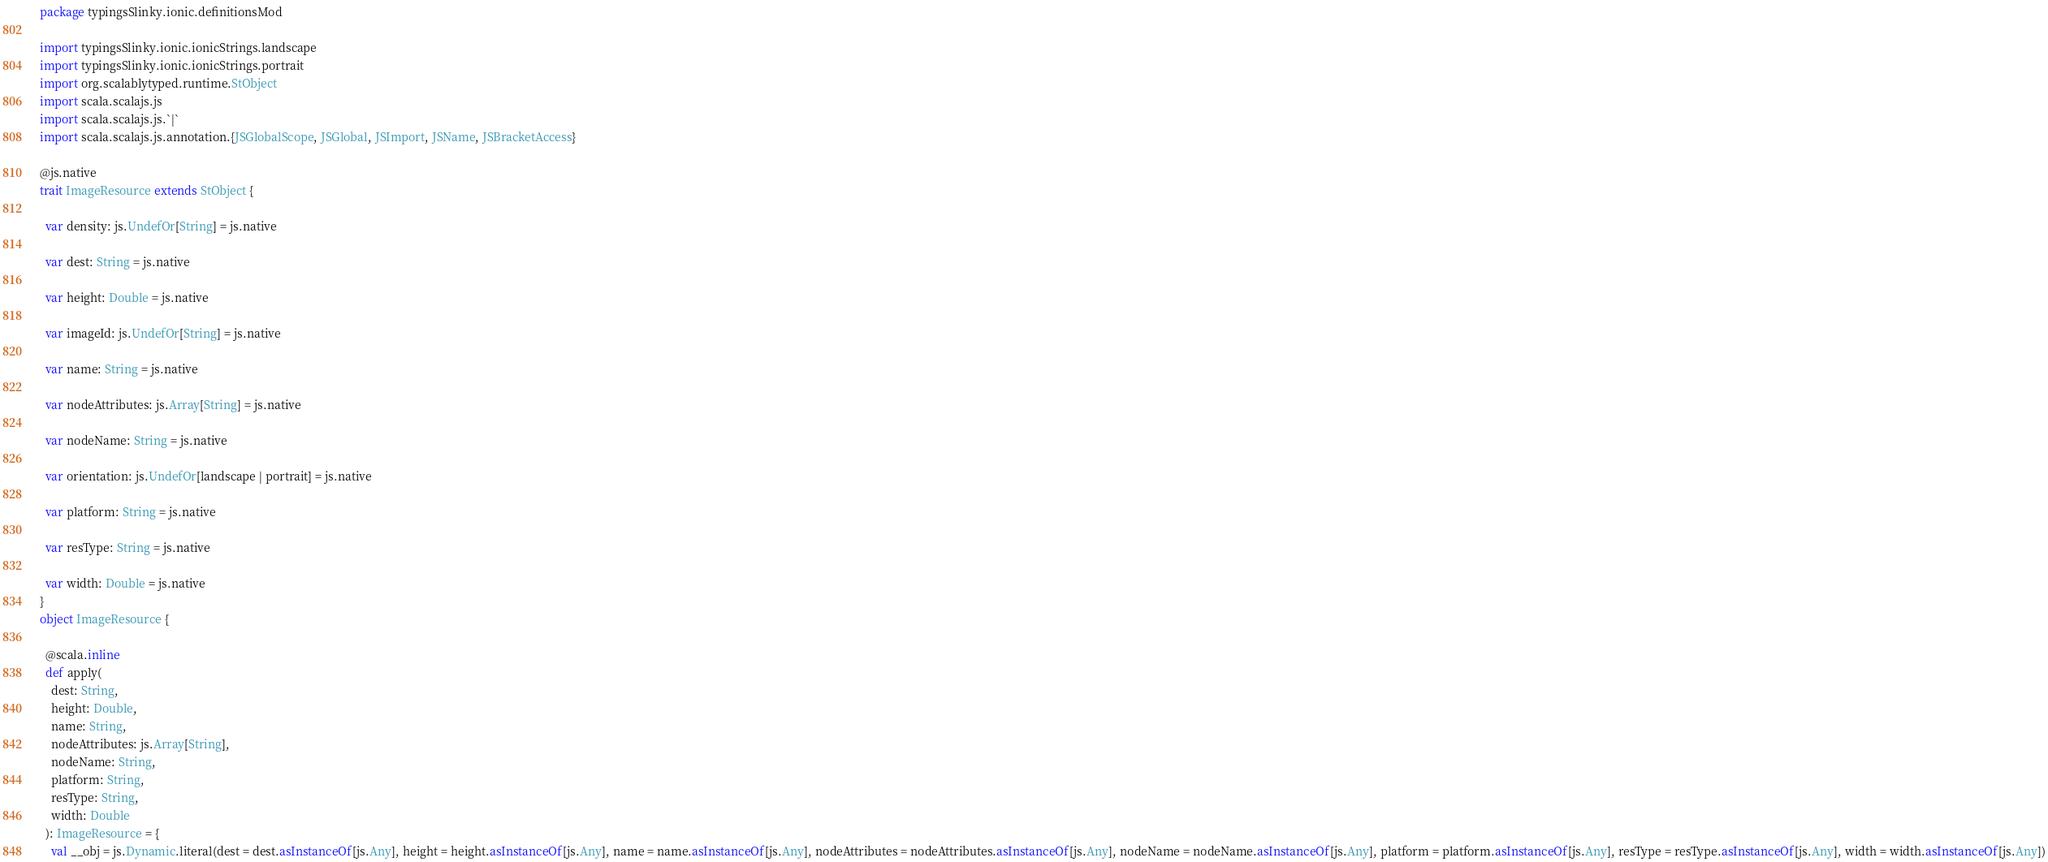Convert code to text. <code><loc_0><loc_0><loc_500><loc_500><_Scala_>package typingsSlinky.ionic.definitionsMod

import typingsSlinky.ionic.ionicStrings.landscape
import typingsSlinky.ionic.ionicStrings.portrait
import org.scalablytyped.runtime.StObject
import scala.scalajs.js
import scala.scalajs.js.`|`
import scala.scalajs.js.annotation.{JSGlobalScope, JSGlobal, JSImport, JSName, JSBracketAccess}

@js.native
trait ImageResource extends StObject {
  
  var density: js.UndefOr[String] = js.native
  
  var dest: String = js.native
  
  var height: Double = js.native
  
  var imageId: js.UndefOr[String] = js.native
  
  var name: String = js.native
  
  var nodeAttributes: js.Array[String] = js.native
  
  var nodeName: String = js.native
  
  var orientation: js.UndefOr[landscape | portrait] = js.native
  
  var platform: String = js.native
  
  var resType: String = js.native
  
  var width: Double = js.native
}
object ImageResource {
  
  @scala.inline
  def apply(
    dest: String,
    height: Double,
    name: String,
    nodeAttributes: js.Array[String],
    nodeName: String,
    platform: String,
    resType: String,
    width: Double
  ): ImageResource = {
    val __obj = js.Dynamic.literal(dest = dest.asInstanceOf[js.Any], height = height.asInstanceOf[js.Any], name = name.asInstanceOf[js.Any], nodeAttributes = nodeAttributes.asInstanceOf[js.Any], nodeName = nodeName.asInstanceOf[js.Any], platform = platform.asInstanceOf[js.Any], resType = resType.asInstanceOf[js.Any], width = width.asInstanceOf[js.Any])</code> 